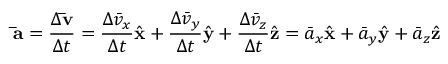<formula> <loc_0><loc_0><loc_500><loc_500>\bar { a } = { \frac { \Delta \bar { v } } { \Delta t } } = { \frac { \Delta { \bar { v } } _ { x } } { \Delta t } } { \hat { x } } + { \frac { \Delta { \bar { v } } _ { y } } { \Delta t } } { \hat { y } } + { \frac { \Delta { \bar { v } } _ { z } } { \Delta t } } { \hat { z } } = { \bar { a } } _ { x } { \hat { x } } + { \bar { a } } _ { y } { \hat { y } } + { \bar { a } } _ { z } { \hat { z } }</formula> 